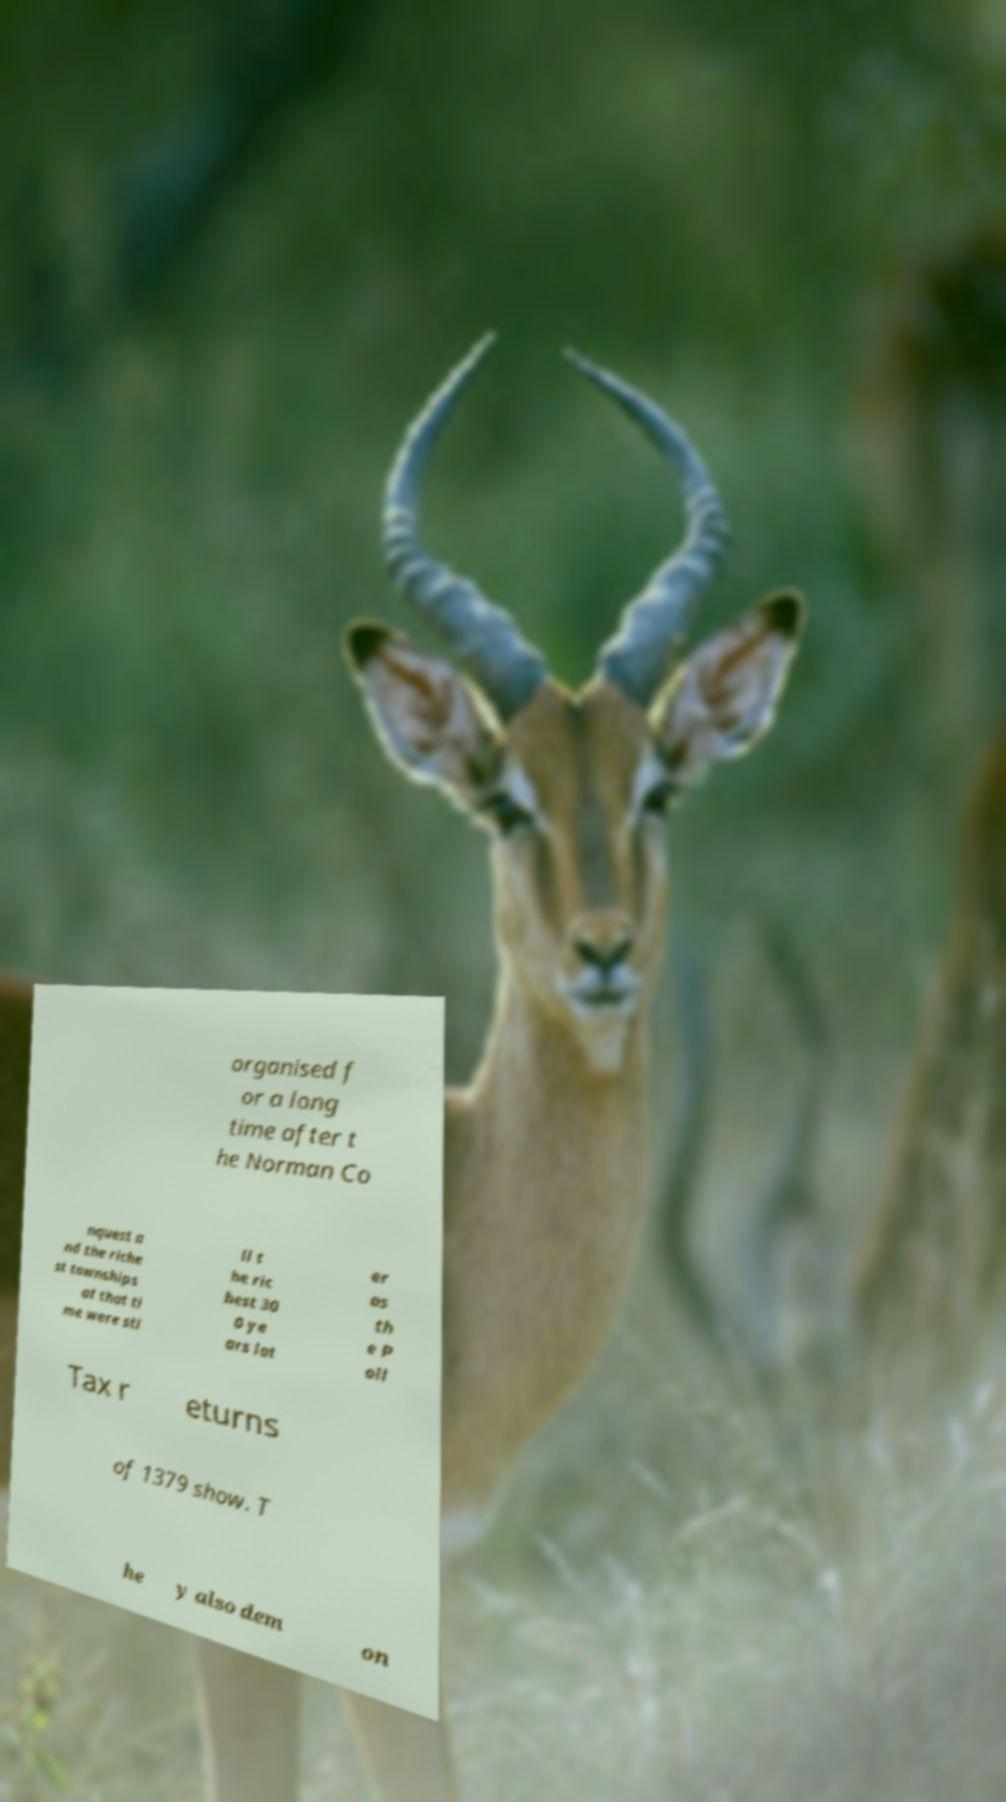What messages or text are displayed in this image? I need them in a readable, typed format. organised f or a long time after t he Norman Co nquest a nd the riche st townships at that ti me were sti ll t he ric hest 30 0 ye ars lat er as th e P oll Tax r eturns of 1379 show. T he y also dem on 